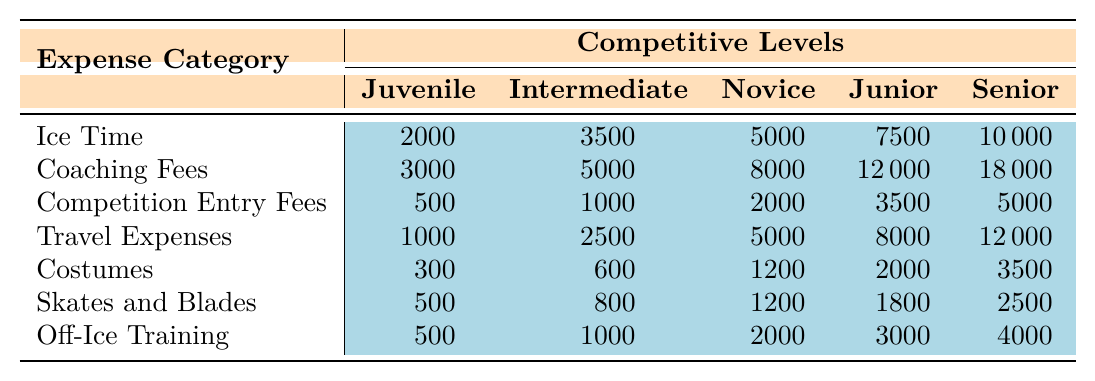What is the cost of Ice Time at the Senior level? The Senior row under the Ice Time column shows a value of 10000.
Answer: 10000 What is the total cost for all expenses at the Juvenile level? Summing all expenses for the Juvenile level: 2000 (Ice Time) + 3000 (Coaching Fees) + 500 (Competition Entry Fees) + 1000 (Travel Expenses) + 300 (Costumes) + 500 (Skates and Blades) + 500 (Off-Ice Training) equals 10000.
Answer: 10000 Did the Competition Entry Fees increase from Junior to Senior level? The Competition Entry Fees for Junior is 3500 and for Senior is 5000; since 5000 is greater than 3500, this is an increase.
Answer: Yes What is the average cost of Travel Expenses across all competitive levels? To find the average, add all Travel Expenses: 1000 + 2500 + 5000 + 8000 + 12000 = 32,500. Then, divide by 5 (number of levels) to get 32,500 / 5 = 6500.
Answer: 6500 Which expense category has the highest cost at the Senior level? Looking at the Senior level row, the highest value is in Coaching Fees, which is 18000.
Answer: Coaching Fees What is the difference in cost between Ice Time at Intermediate and Novice levels? The Ice Time costs are 3500 (Intermediate) and 5000 (Novice). Subtracting these gives 5000 - 3500 = 1500.
Answer: 1500 What is the combined cost of Costumes and Skates and Blades at the Junior level? For the Junior level, Costumes cost 2000 and Skates and Blades cost 1800. Adding these gives 2000 + 1800 = 3800.
Answer: 3800 Is the cost of Off-Ice Training at Novice level greater than the cost of Ice Time at Intermediate level? The Off-Ice Training cost at Novice is 2000, and the Ice Time cost at Intermediate is 3500. Since 2000 is not greater than 3500, the statement is false.
Answer: No What is the total cost for all expenses at the Senior level compared to the Juvenile level? The Senior level total is: 10000 (Ice Time) + 18000 (Coaching Fees) + 5000 (Competition Entry) + 12000 (Travel) + 3500 (Costumes) + 2500 (Skates and Blades) + 4000 (Off-Ice) = 50000. The Juvenile level total is 10000. 50000 is greater than 10000.
Answer: 50000 is greater Which expense has the least cost at the Novice level? At the Novice level, the costs are: 5000 (Ice Time), 8000 (Coaching Fees), 2000 (Competition Entry Fees), 5000 (Travel), 1200 (Costumes), 1200 (Skates and Blades), and 2000 (Off-Ice Training). The least cost is 1200 for Costumes and Skates and Blades.
Answer: Costumes and Skates and Blades 